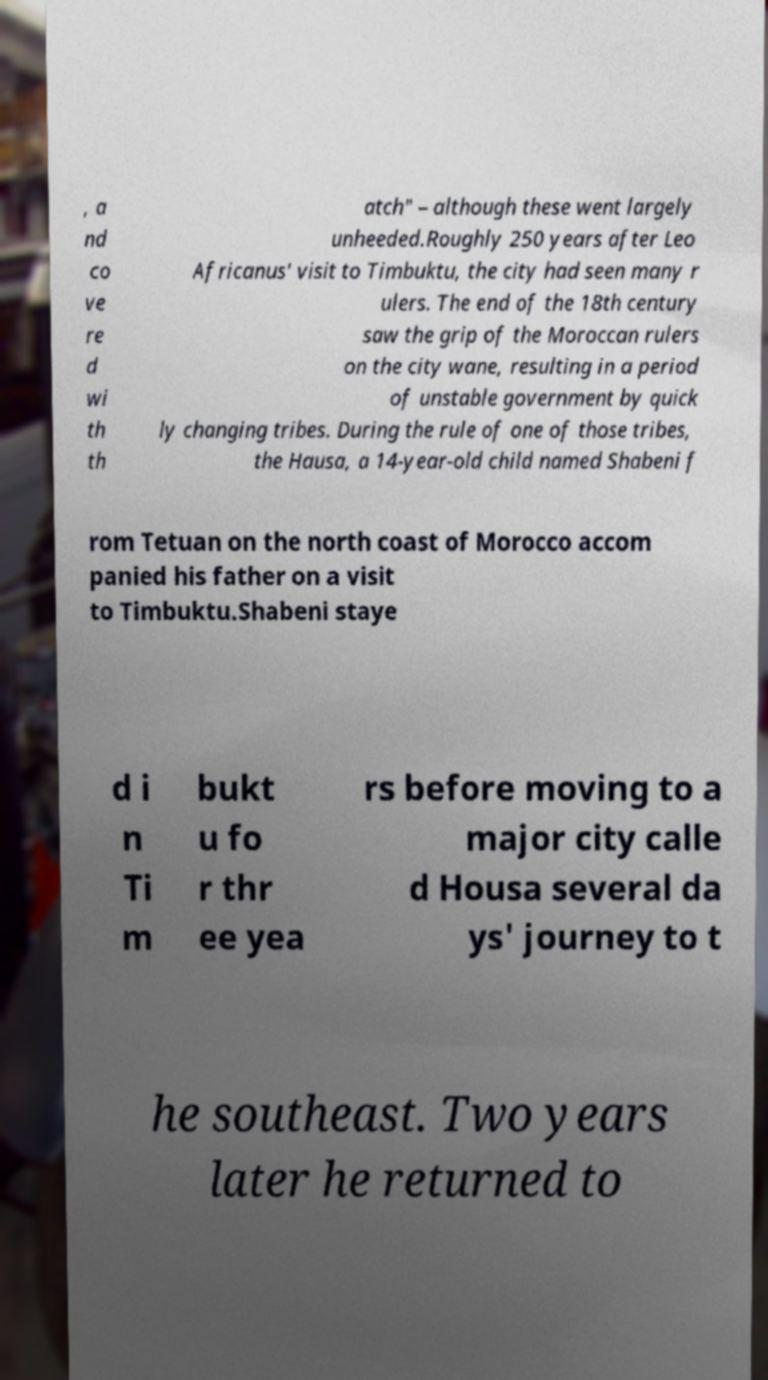For documentation purposes, I need the text within this image transcribed. Could you provide that? , a nd co ve re d wi th th atch" – although these went largely unheeded.Roughly 250 years after Leo Africanus' visit to Timbuktu, the city had seen many r ulers. The end of the 18th century saw the grip of the Moroccan rulers on the city wane, resulting in a period of unstable government by quick ly changing tribes. During the rule of one of those tribes, the Hausa, a 14-year-old child named Shabeni f rom Tetuan on the north coast of Morocco accom panied his father on a visit to Timbuktu.Shabeni staye d i n Ti m bukt u fo r thr ee yea rs before moving to a major city calle d Housa several da ys' journey to t he southeast. Two years later he returned to 